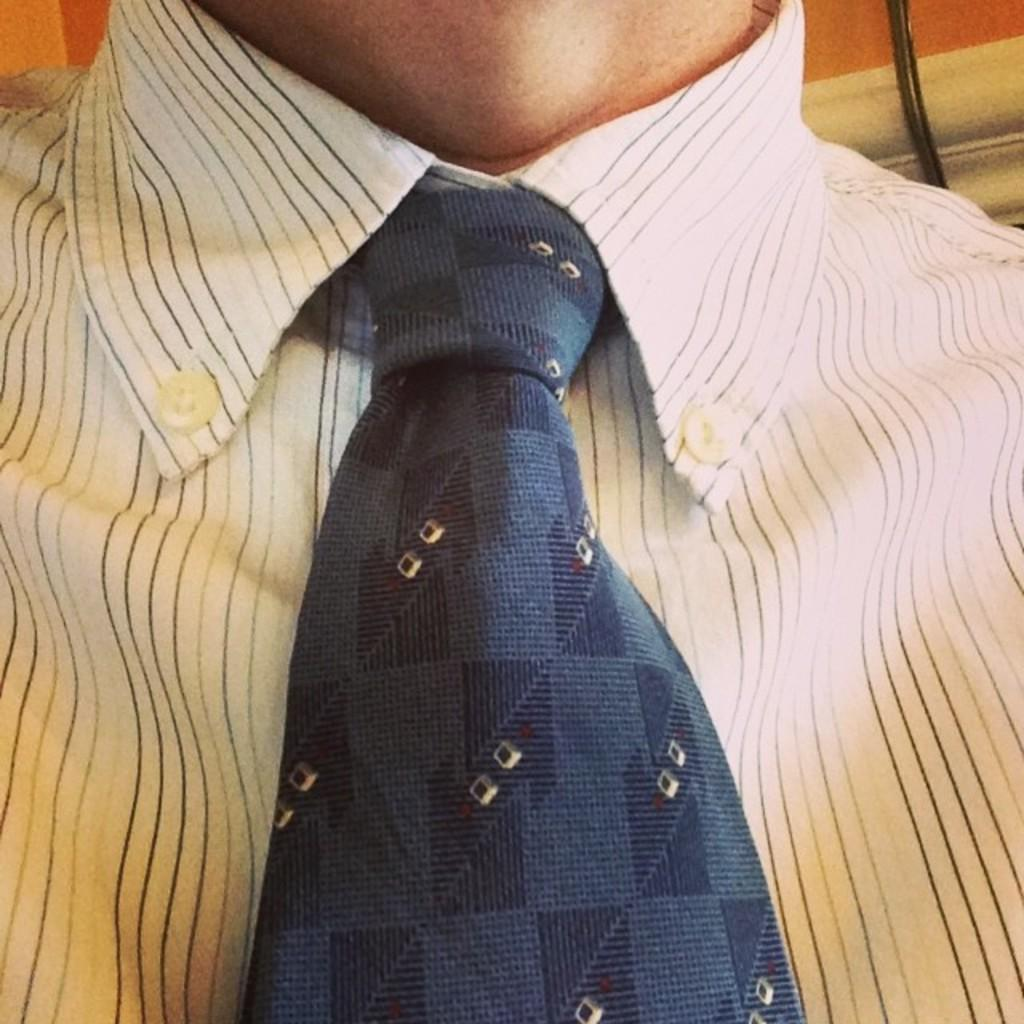What type of clothing is the human wearing in the image? The human is wearing a shirt and tie in the image. What feature can be observed on the shirt? The shirt has buttons. What object can be seen on the right side of the image? There is a wire visible on the right side of the image. What is the weather like in the image? The provided facts do not mention any information about the weather, so it cannot be determined from the image. What organization does the human belong to in the image? There is no information provided about the human's affiliation or organization in the image. 